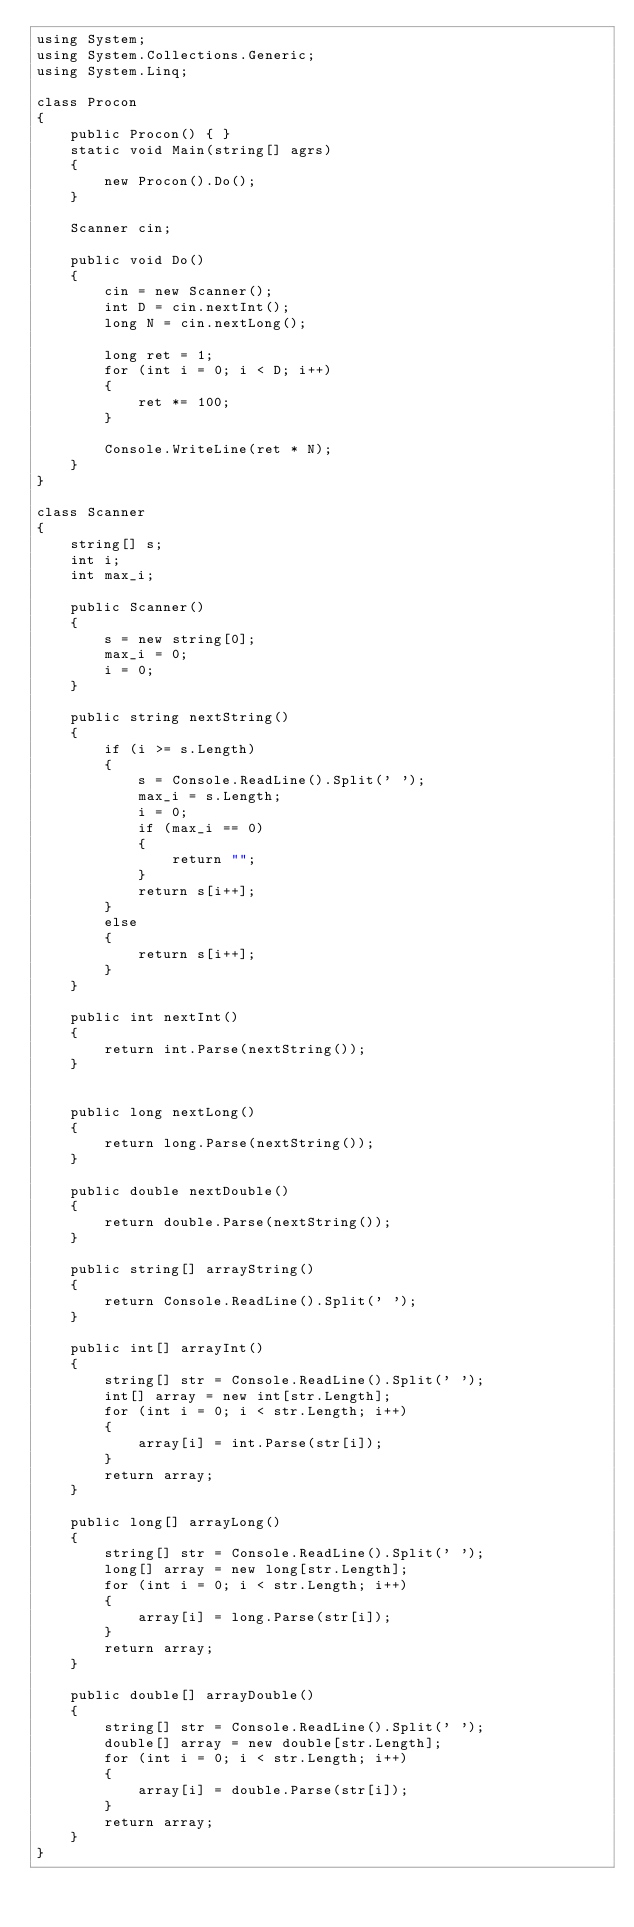Convert code to text. <code><loc_0><loc_0><loc_500><loc_500><_C#_>using System;
using System.Collections.Generic;
using System.Linq;

class Procon
{
    public Procon() { }
    static void Main(string[] agrs)
    {
        new Procon().Do();
    }

    Scanner cin;

    public void Do()
    {
        cin = new Scanner();
        int D = cin.nextInt();
        long N = cin.nextLong();

        long ret = 1;
        for (int i = 0; i < D; i++)
        {
            ret *= 100;
        }

        Console.WriteLine(ret * N);
    }
}

class Scanner
{
    string[] s;
    int i;
    int max_i;

    public Scanner()
    {
        s = new string[0];
        max_i = 0;
        i = 0;
    }

    public string nextString()
    {
        if (i >= s.Length)
        {
            s = Console.ReadLine().Split(' ');
            max_i = s.Length;
            i = 0;
            if (max_i == 0)
            {
                return "";
            }
            return s[i++];
        }
        else
        {
            return s[i++];
        }
    }

    public int nextInt()
    {
        return int.Parse(nextString());
    }


    public long nextLong()
    {
        return long.Parse(nextString());
    }

    public double nextDouble()
    {
        return double.Parse(nextString());
    }

    public string[] arrayString()
    {
        return Console.ReadLine().Split(' ');
    }

    public int[] arrayInt()
    {
        string[] str = Console.ReadLine().Split(' ');
        int[] array = new int[str.Length];
        for (int i = 0; i < str.Length; i++)
        {
            array[i] = int.Parse(str[i]);
        }
        return array;
    }

    public long[] arrayLong()
    {
        string[] str = Console.ReadLine().Split(' ');
        long[] array = new long[str.Length];
        for (int i = 0; i < str.Length; i++)
        {
            array[i] = long.Parse(str[i]);
        }
        return array;
    }

    public double[] arrayDouble()
    {
        string[] str = Console.ReadLine().Split(' ');
        double[] array = new double[str.Length];
        for (int i = 0; i < str.Length; i++)
        {
            array[i] = double.Parse(str[i]);
        }
        return array;
    }
}</code> 